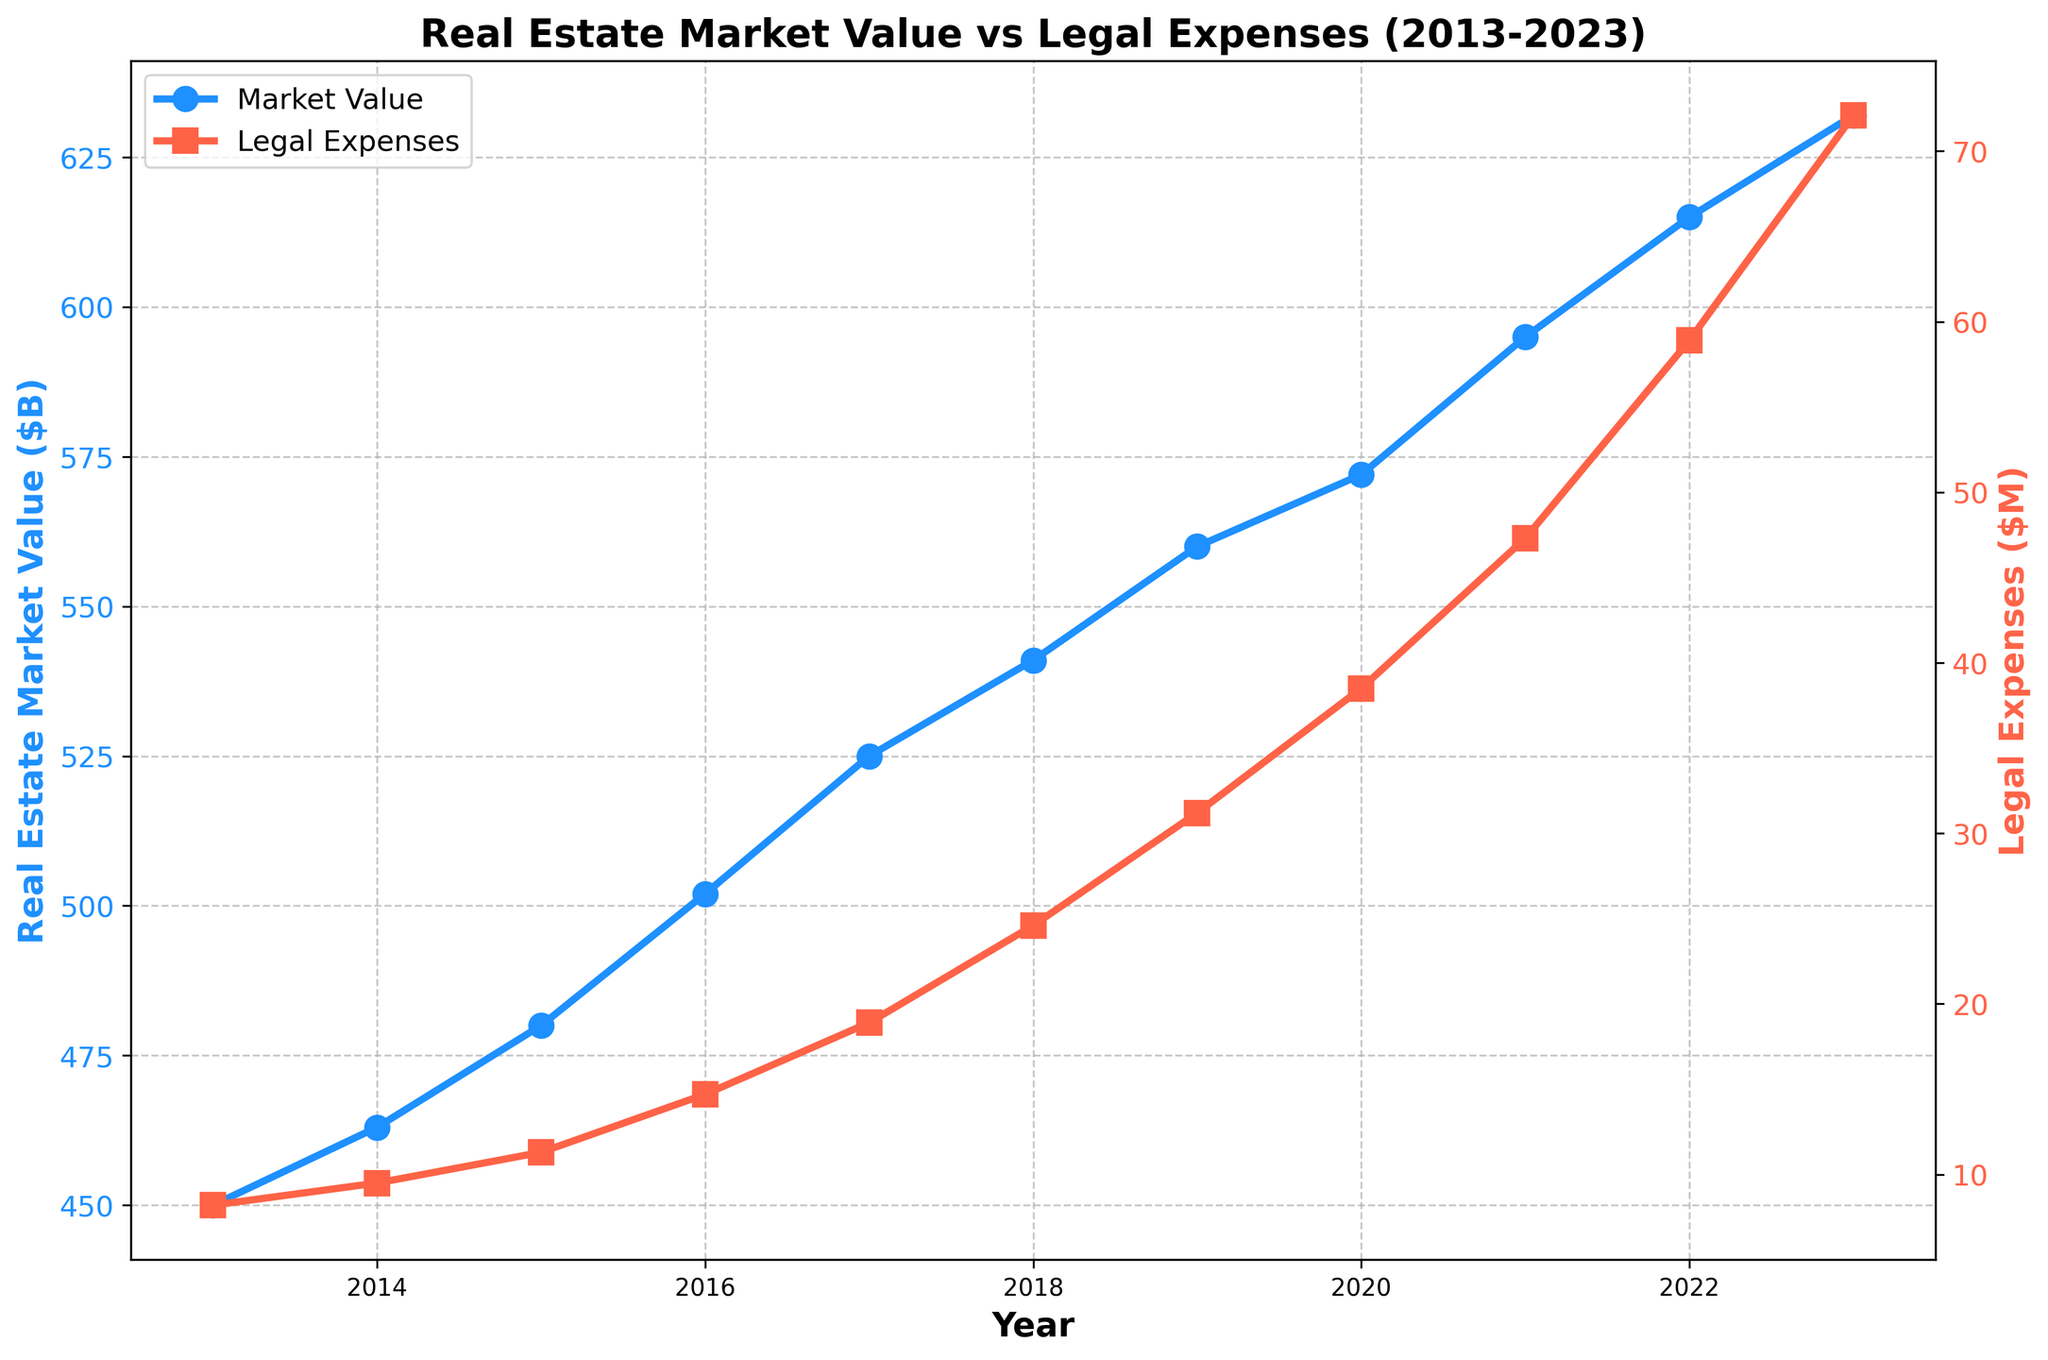What is the increase in Real Estate Market Value from 2013 to 2023? To find this, subtract the market value in 2013 from the market value in 2023: 632 - 450 = 182
Answer: 182 How does the trend of Legal Expenses compare to the trend of Real Estate Market Value? Both trends are increasing over time. However, Legal Expenses are increasing at a higher rate compared to the Real Estate Market Value. This can be seen by the steeper slope of the Legal Expenses curve.
Answer: Legal Expenses increase at a higher rate Which year saw the highest growth in Real Estate Market Value and by how much? The highest growth can be determined by finding the maximum difference between consecutive years. From the data: 2023-2022: 17, 2022-2021: 20, 2021-2020: 23, 2020-2019: 12, and so on. The highest difference is 23 (2021-2020).
Answer: 2021, 23 By what percentage did Legal Expenses increase from 2013 to 2023? First, find the difference: 72.1 - 8.2 = 63.9. Then calculate the percentage increase: (63.9 / 8.2) * 100 ≈ 779.27%
Answer: ≈ 779.27% In which year do Legal Expenses overtake $50M? Check the data for when Legal Expenses first exceed $50M, which happens in 2021 with $58.9M.
Answer: 2021 What is the average Real Estate Market Value over the 11 years? Sum all the market values and divide by the number of years: (450 + 463 + 480 + 502 + 525 + 541 + 560 + 572 + 595 + 615 + 632) / 11 = 524.64
Answer: 524.64 What is the ratio of Legal Expenses to Real Estate Market Value in 2023? Divide Legal Expenses by Real Estate Market Value in 2023: 72.1 / 632 ≈ 0.114
Answer: ≈ 0.114 Which year had the smallest increase in Legal Expenses compared to the previous year? Calculate the yearly increases: 2023-2022: 13.2, 2022-2021: 11.6, 2021-2020: 8.8, 2020-2019: 7.3, and so on. The smallest increase is 1.3 from 2019-2018.
Answer: 2014 What color represents Real Estate Market Value in the plot? The color representing Real Estate Market Value is blue, as indicated by the description.
Answer: blue Comparing the visual heights of the two lines in 2023, which one is higher and why? The Real Estate Market Value line is higher because it corresponds to a larger numerical value (632) compared to Legal Expenses (72.1).
Answer: Real Estate Market Value 